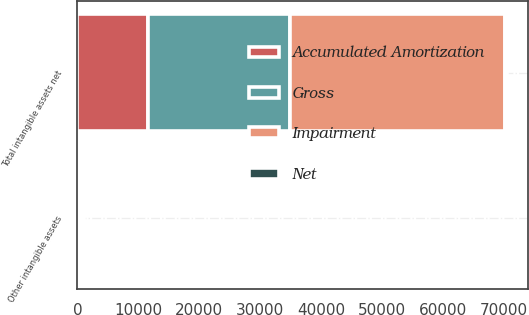<chart> <loc_0><loc_0><loc_500><loc_500><stacked_bar_chart><ecel><fcel>Other intangible assets<fcel>Total intangible assets net<nl><fcel>Impairment<fcel>500<fcel>35287<nl><fcel>Accumulated Amortization<fcel>148<fcel>11522<nl><fcel>Net<fcel>291<fcel>291<nl><fcel>Gross<fcel>61<fcel>23474<nl></chart> 